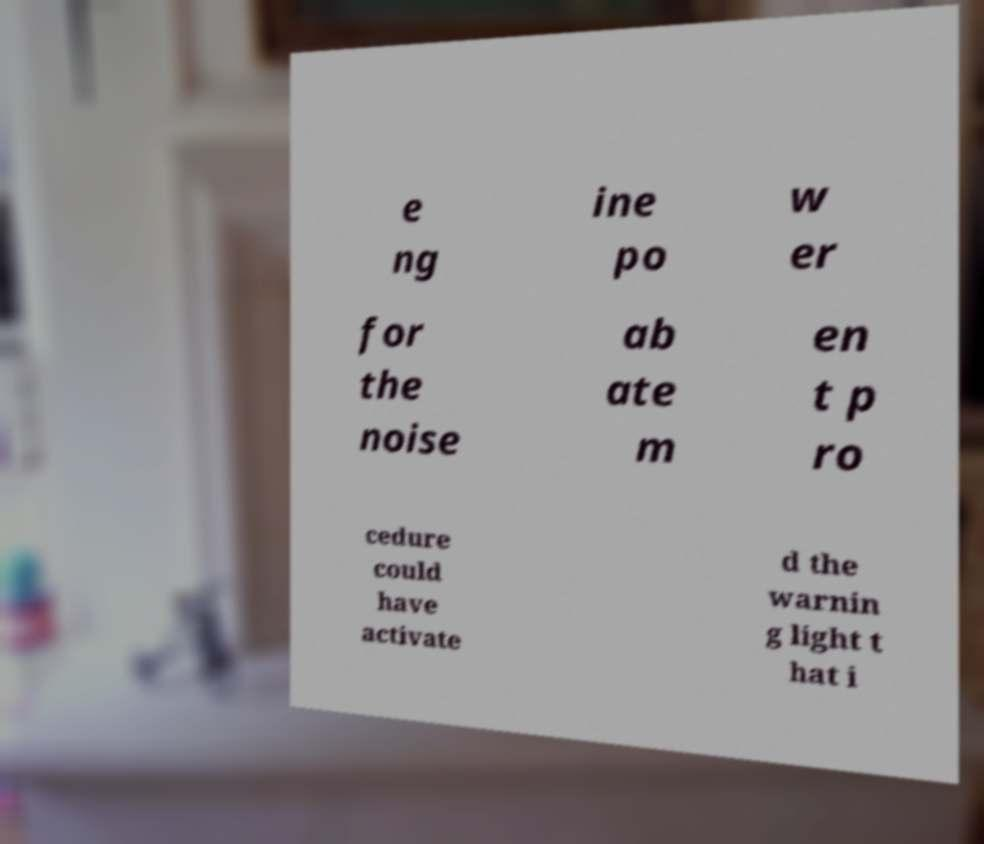Can you read and provide the text displayed in the image?This photo seems to have some interesting text. Can you extract and type it out for me? e ng ine po w er for the noise ab ate m en t p ro cedure could have activate d the warnin g light t hat i 